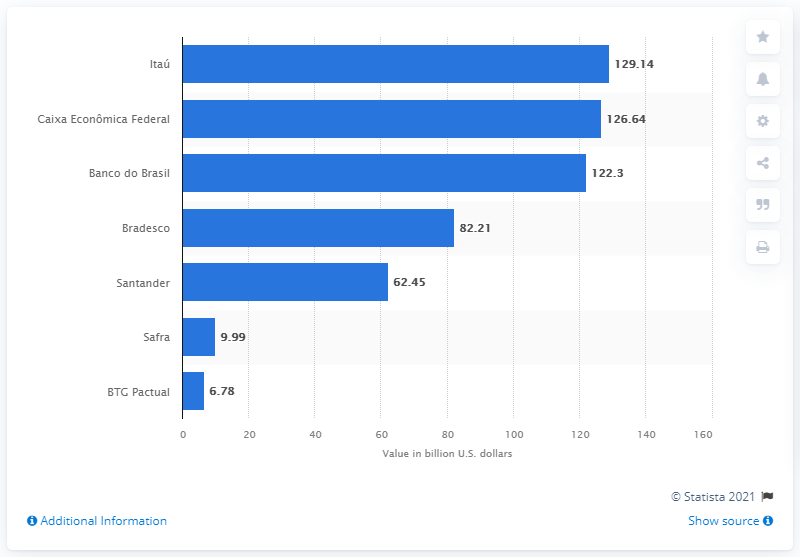How many dollars did Itao Unibanco deposit as of September 2019?
 129.14 